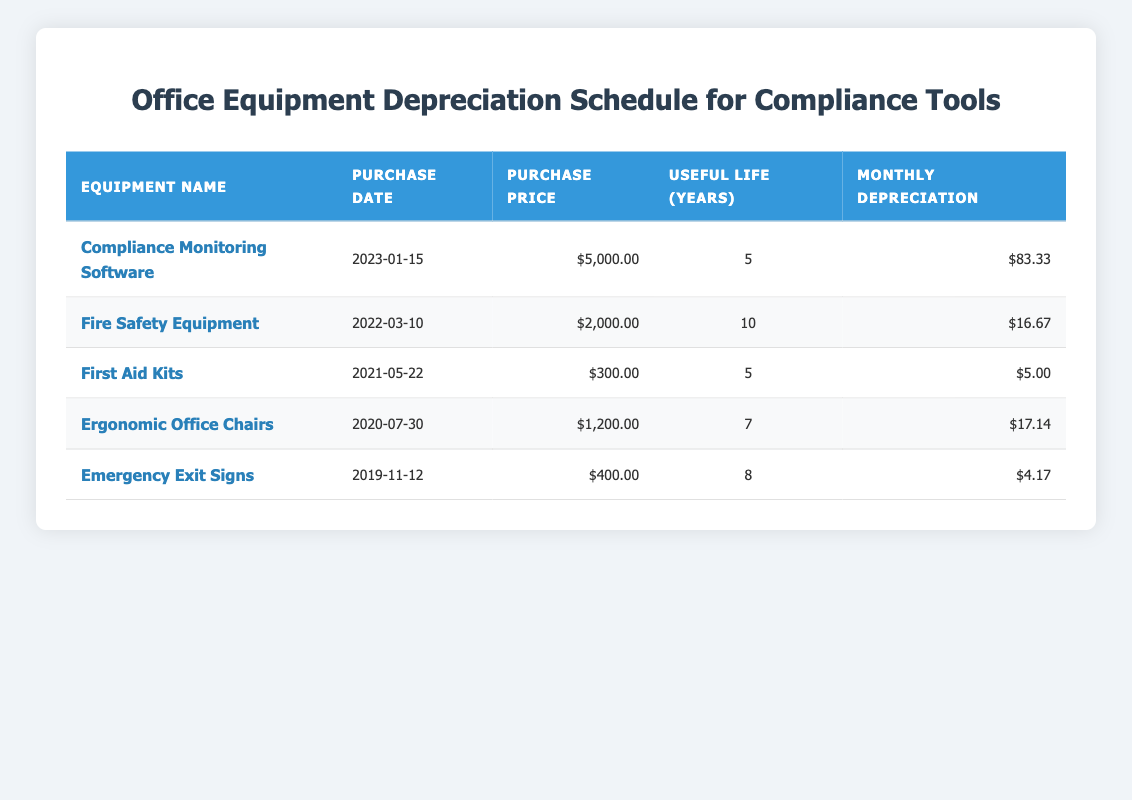What is the purchase price of the Compliance Monitoring Software? The table lists the purchase price of the Compliance Monitoring Software under the "Purchase Price" column. It is stated as $5,000.00.
Answer: $5,000.00 What is the monthly depreciation of the Fire Safety Equipment? The monthly depreciation for the Fire Safety Equipment is provided in the "Monthly Depreciation" column. It shows as $16.67.
Answer: $16.67 Is the useful life of the First Aid Kits greater than that of the Emergency Exit Signs? The useful life for First Aid Kits is 5 years and for Emergency Exit Signs is 8 years. Since 5 is less than 8, the statement is false.
Answer: No What is the total purchase price of all the equipment? Summing the purchase prices: $5,000.00 (Compliance Monitoring Software) + $2,000.00 (Fire Safety Equipment) + $300.00 (First Aid Kits) + $1,200.00 (Ergonomic Office Chairs) + $400.00 (Emergency Exit Signs) equals $8,900.00.
Answer: $8,900.00 Which equipment has the highest monthly depreciation? By looking at the monthly depreciation values, Compliance Monitoring Software has $83.33, which is higher than all other equipment, making it the highest.
Answer: Compliance Monitoring Software 